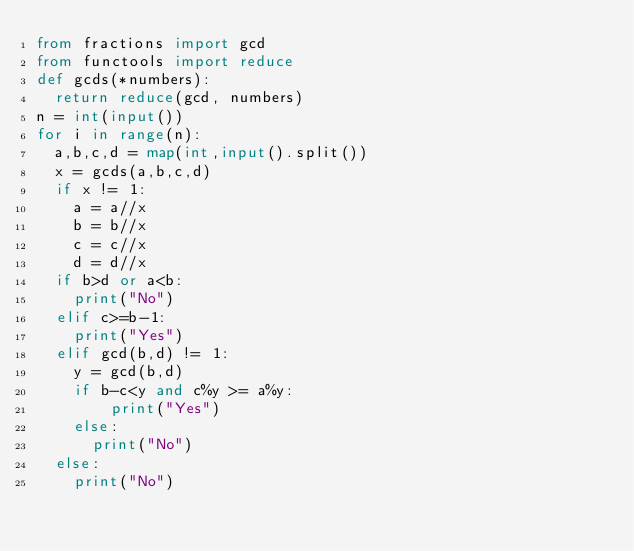Convert code to text. <code><loc_0><loc_0><loc_500><loc_500><_Python_>from fractions import gcd
from functools import reduce
def gcds(*numbers):
  return reduce(gcd, numbers)
n = int(input())
for i in range(n):
  a,b,c,d = map(int,input().split())
  x = gcds(a,b,c,d)
  if x != 1:
    a = a//x
    b = b//x
    c = c//x
    d = d//x
  if b>d or a<b:
    print("No")
  elif c>=b-1:
    print("Yes")
  elif gcd(b,d) != 1:
    y = gcd(b,d)
    if b-c<y and c%y >= a%y:
        print("Yes")
    else:
      print("No")
  else:
    print("No")
</code> 